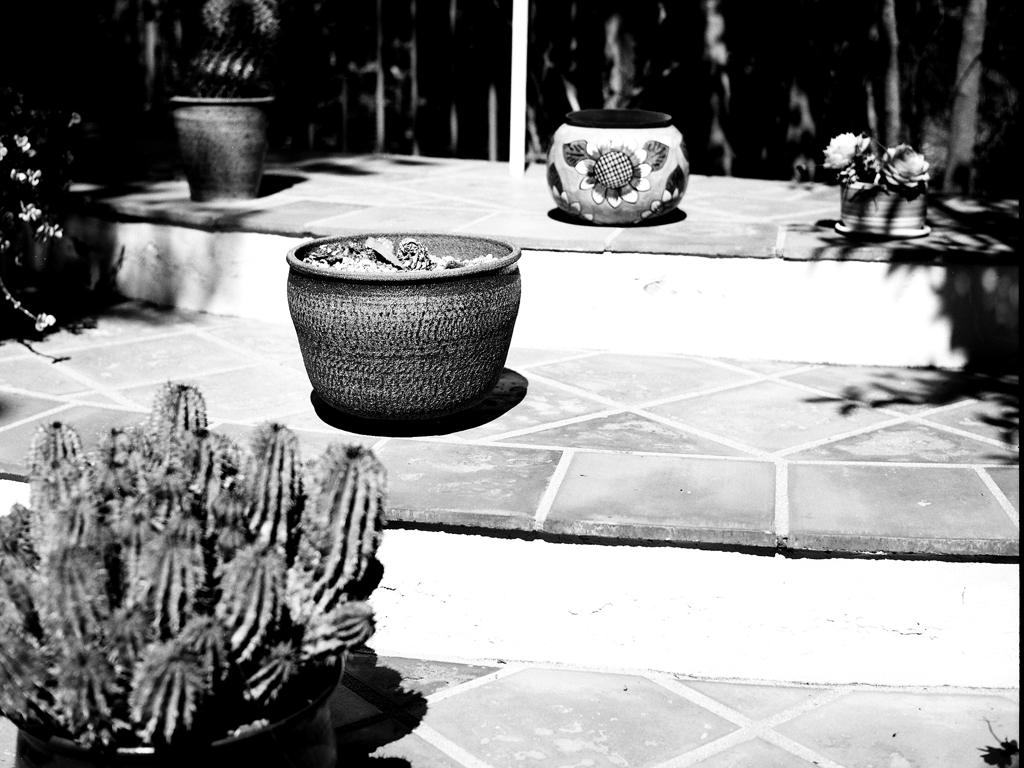What does the choice of black and white photography suggest about the mood or theme of the image? The use of black and white in this photograph could suggest a sense of nostalgia or timelessness. It strips away the distractions of color, emphasizing textures, shapes, and the interplay of light and shadow. This artistic choice can elicit a contemplative mood, inviting viewers to focus on the structural beauty of the plants and the peaceful ambiance of the garden setting. 